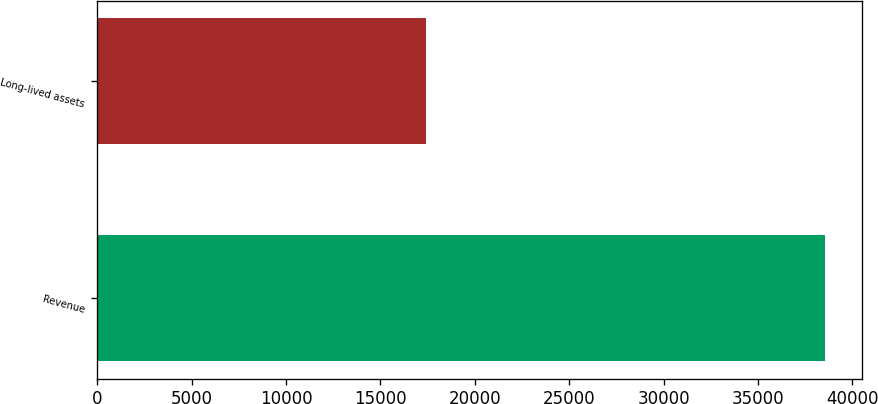<chart> <loc_0><loc_0><loc_500><loc_500><bar_chart><fcel>Revenue<fcel>Long-lived assets<nl><fcel>38553<fcel>17422<nl></chart> 